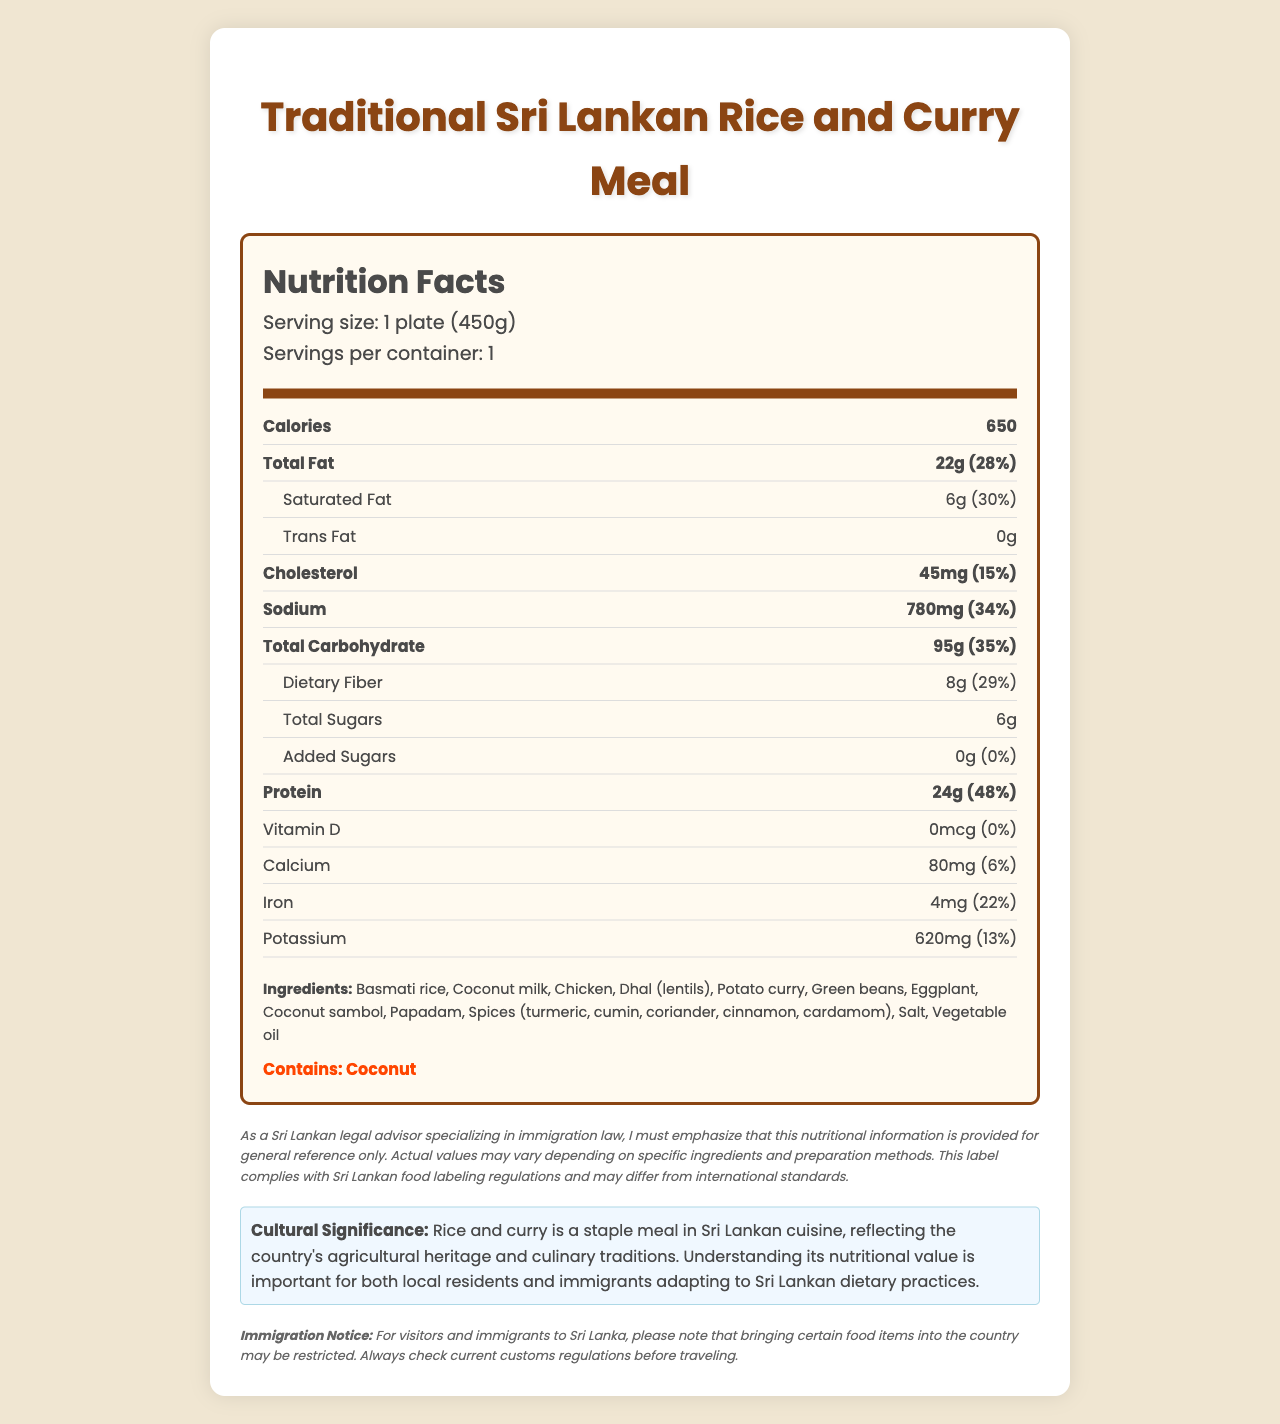what is the serving size for the Traditional Sri Lankan Rice and Curry Meal? The serving size is listed under the section "Serving size".
Answer: 1 plate (450g) how many calories are in one serving of this meal? The calorie count is displayed in the "Calories" row.
Answer: 650 what is the daily value percentage for total fat in this meal? The daily value percentage for total fat is found in the "Total Fat" row, next to its amount.
Answer: 28% how much dietary fiber does this meal provide? The amount of dietary fiber is shown in the "Dietary Fiber" row.
Answer: 8g does the meal contain any added sugars? The "Added Sugars" row shows 0g, indicating there are no added sugars.
Answer: No what is the amount of protein in this meal? The protein amount is provided in the "Protein" row.
Answer: 24g does this meal contain coconut? The allergens section specifies that the meal contains coconut.
Answer: Yes what percentage of the daily value for sodium does one serving contain? The sodium daily value percentage is displayed in the "Sodium" row.
Answer: 34% how much calcium does this meal provide? A. 50 mg B. 80 mg C. 100 mg D. 120 mg The calcium amount is listed in the "Calcium" row.
Answer: B. 80 mg which ingredient is not listed in the ingredients section? A. Lentils B. Papadam C. Spinach Spinach is not mentioned in the listed ingredients, which include lentils and papadam.
Answer: C. Spinach is there trans fat in the meal? The "Trans Fat" row shows 0g, meaning there is no trans fat in the meal.
Answer: No summarize the nutritional content of this Traditional Sri Lankan Rice and Curry Meal. The document lists the nutritional values of various nutrients contained in a single serving of the meal, along with their respective percentages of daily intake values.
Answer: The meal, with a serving size of 1 plate (450g), contains 650 calories, 22g of total fat, 6g of saturated fat, 45mg of cholesterol, 780mg of sodium, 95g of total carbohydrate, 8g of dietary fiber, 6g of total sugars, and no added sugars. It also provides 24g of protein. Additionally, it contains 0mcg of vitamin D, 80mg of calcium, 4mg of iron, and 620mg of potassium. what is the cultural significance of rice and curry in Sri Lanka according to the document? The cultural significance is described at the end of the document under "Cultural Significance".
Answer: Rice and curry is a staple meal in Sri Lankan cuisine, reflecting the country's agricultural heritage and culinary traditions. Understanding its nutritional value is important for both local residents and immigrants adapting to Sri Lankan dietary practices. how does this label comply with food labeling regulations? The legal disclaimer states that the label complies with Sri Lankan food labeling regulations.
Answer: Complies with Sri Lankan food labeling regulations. what preparations methods could alter these nutritional values? The document does not provide any specifics on how different preparation methods could change the nutritional values.
Answer: Not enough information 